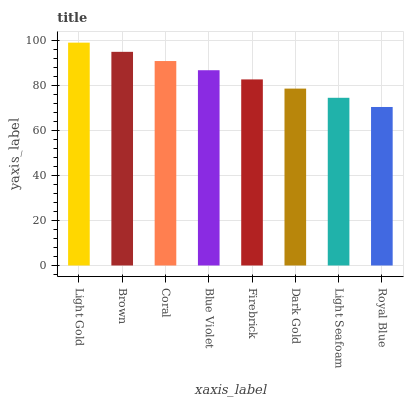Is Royal Blue the minimum?
Answer yes or no. Yes. Is Light Gold the maximum?
Answer yes or no. Yes. Is Brown the minimum?
Answer yes or no. No. Is Brown the maximum?
Answer yes or no. No. Is Light Gold greater than Brown?
Answer yes or no. Yes. Is Brown less than Light Gold?
Answer yes or no. Yes. Is Brown greater than Light Gold?
Answer yes or no. No. Is Light Gold less than Brown?
Answer yes or no. No. Is Blue Violet the high median?
Answer yes or no. Yes. Is Firebrick the low median?
Answer yes or no. Yes. Is Brown the high median?
Answer yes or no. No. Is Dark Gold the low median?
Answer yes or no. No. 